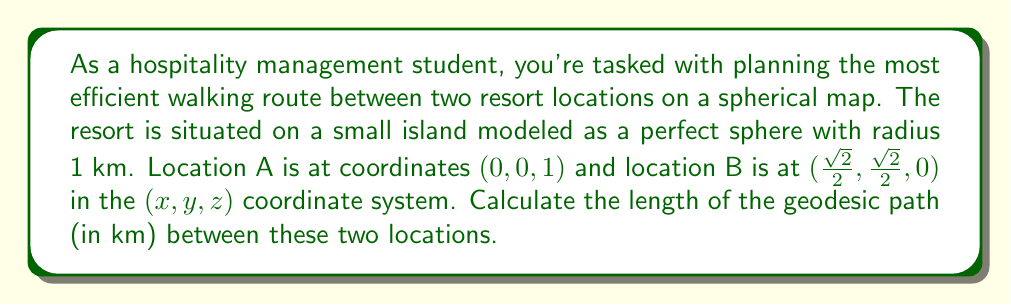Teach me how to tackle this problem. To solve this problem, we'll follow these steps:

1) First, recall that on a sphere, the geodesic path between two points is the great circle arc connecting them.

2) The length of this arc is given by the formula:

   $$s = R \cdot \arccos(\cos\theta_1\cos\theta_2 + \sin\theta_1\sin\theta_2\cos(\phi_2 - \phi_1))$$

   where $R$ is the radius of the sphere, $\theta$ is the colatitude (90° - latitude), and $\phi$ is the longitude.

3) In our case, $R = 1$ km. We need to convert our Cartesian coordinates to spherical coordinates.

4) For point A $(0, 0, 1)$:
   $\theta_1 = \arccos(1) = 0$
   $\phi_1$ is undefined, but this won't affect our calculation.

5) For point B $(\frac{\sqrt{2}}{2}, \frac{\sqrt{2}}{2}, 0)$:
   $\theta_2 = \arccos(0) = \frac{\pi}{2}$
   $\phi_2 = \frac{\pi}{4}$

6) Substituting these values into our formula:

   $$s = \arccos(\cos(0)\cos(\frac{\pi}{2}) + \sin(0)\sin(\frac{\pi}{2})\cos(\frac{\pi}{4} - 0))$$

7) Simplifying:
   $$s = \arccos(0 \cdot 0 + 0 \cdot 1 \cdot \cos(\frac{\pi}{4})) = \arccos(0) = \frac{\pi}{2}$$

8) Therefore, the length of the geodesic path is $\frac{\pi}{2}$ km.
Answer: $\frac{\pi}{2}$ km 